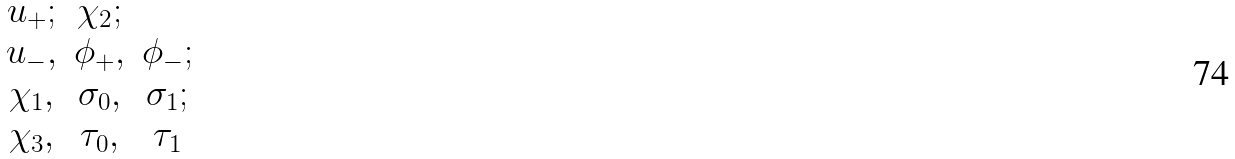Convert formula to latex. <formula><loc_0><loc_0><loc_500><loc_500>\begin{matrix} u _ { + } ; & \chi _ { 2 } ; \\ u _ { - } , & \phi _ { + } , & \phi _ { - } ; \\ \chi _ { 1 } , & \sigma _ { 0 } , & \sigma _ { 1 } ; \\ \chi _ { 3 } , & \tau _ { 0 } , & \tau _ { 1 } \end{matrix}</formula> 